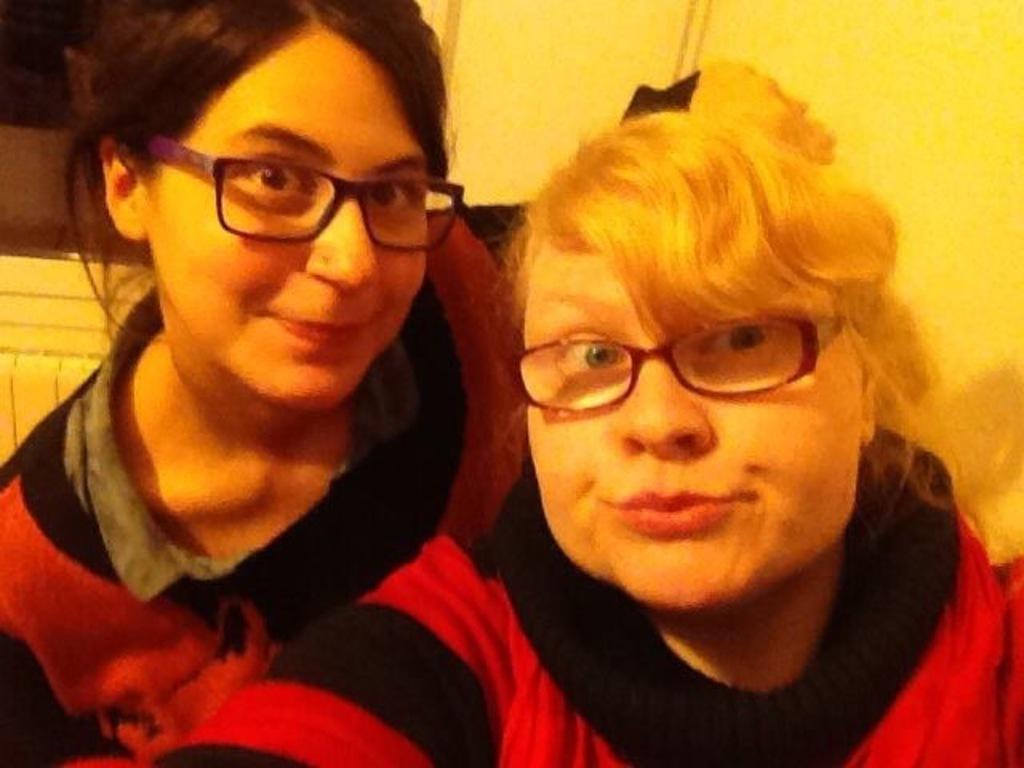Could you give a brief overview of what you see in this image? In the center of the image there are two ladies wearing spectacles. In the background of the image there is wall. 